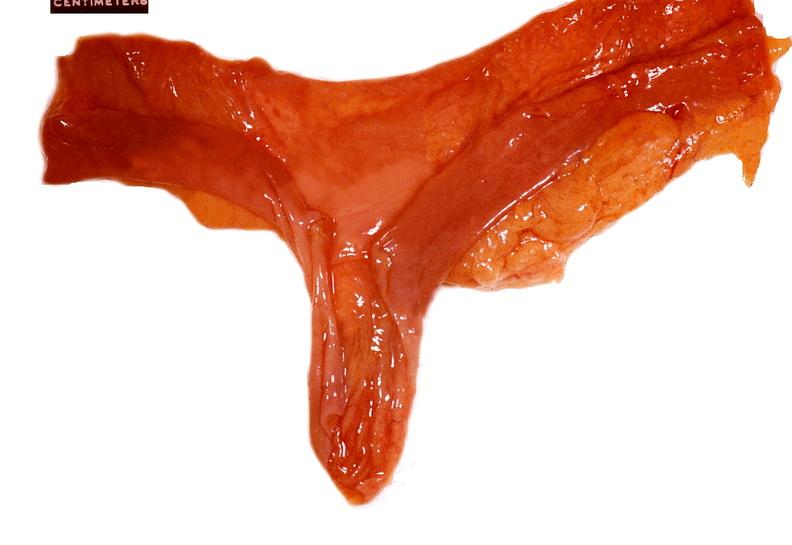does this image show small intestine, meckels diverticulum?
Answer the question using a single word or phrase. Yes 